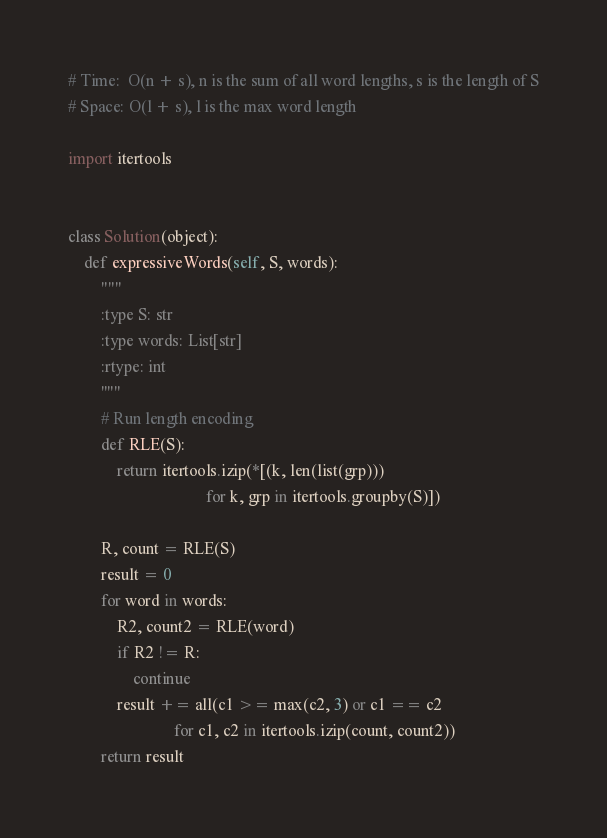<code> <loc_0><loc_0><loc_500><loc_500><_Python_># Time:  O(n + s), n is the sum of all word lengths, s is the length of S
# Space: O(l + s), l is the max word length

import itertools


class Solution(object):
    def expressiveWords(self, S, words):
        """
        :type S: str
        :type words: List[str]
        :rtype: int
        """
        # Run length encoding
        def RLE(S):
            return itertools.izip(*[(k, len(list(grp)))
                                  for k, grp in itertools.groupby(S)])

        R, count = RLE(S)
        result = 0
        for word in words:
            R2, count2 = RLE(word)
            if R2 != R:
                continue
            result += all(c1 >= max(c2, 3) or c1 == c2
                          for c1, c2 in itertools.izip(count, count2))
        return result

</code> 